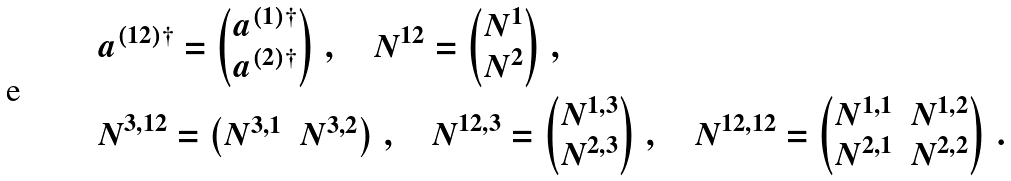Convert formula to latex. <formula><loc_0><loc_0><loc_500><loc_500>& a ^ { ( 1 2 ) \dagger } = \begin{pmatrix} a ^ { ( 1 ) \dagger } \\ a ^ { ( 2 ) \dagger } \end{pmatrix} \, , \quad N ^ { 1 2 } = \begin{pmatrix} N ^ { 1 } \\ N ^ { 2 } \end{pmatrix} \, , \\ & N ^ { 3 , 1 2 } = \begin{pmatrix} N ^ { 3 , 1 } & N ^ { 3 , 2 } \end{pmatrix} \, , \quad N ^ { 1 2 , 3 } = \begin{pmatrix} N ^ { 1 , 3 } \\ N ^ { 2 , 3 } \end{pmatrix} \, , \quad N ^ { 1 2 , 1 2 } = \begin{pmatrix} N ^ { 1 , 1 } & N ^ { 1 , 2 } \\ N ^ { 2 , 1 } & N ^ { 2 , 2 } \end{pmatrix} \, .</formula> 